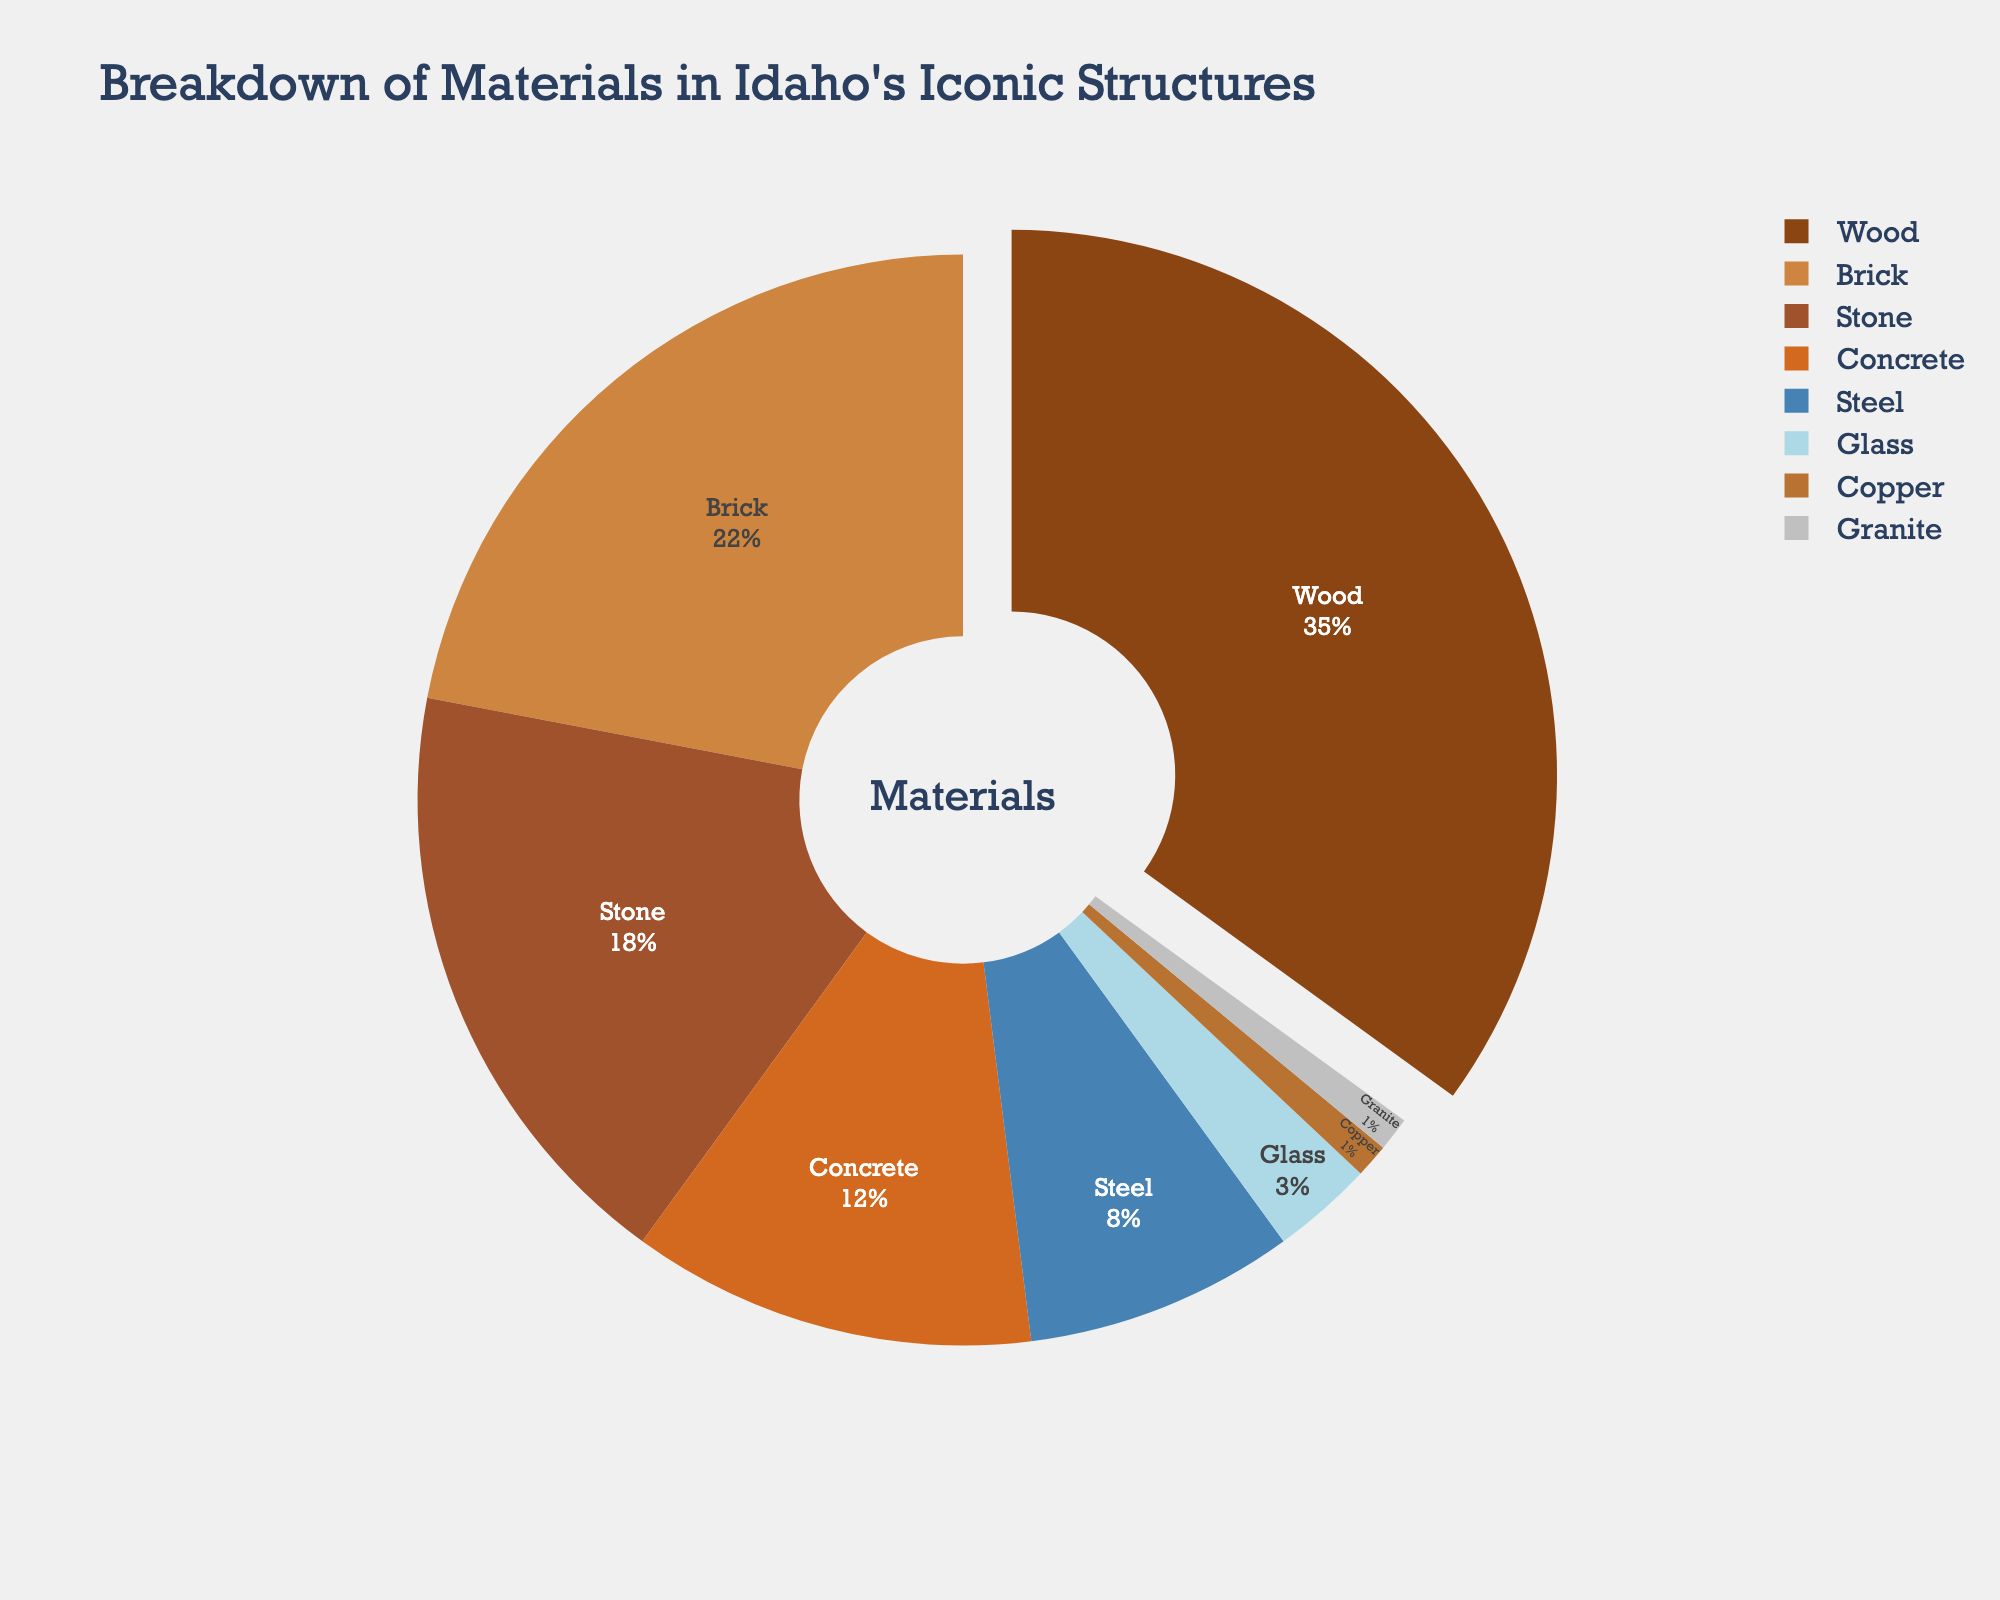What material is used the most in Idaho's iconic structures? The largest section of the pie chart represents the material that is used the most. The color associated with this section is brown, and the label indicates it is wood.
Answer: Wood Which material is used the least in Idaho's iconic structures? In a pie chart, the smallest segment represents the material that is used the least. The chart shows the smallest segments are copper and granite, both consisting of 1% each.
Answer: Copper and granite How much more percentage is wood used than steel? First, locate the percentage of wood (35%) and the percentage of steel (8%) from the chart. Then, subtract the percentage of steel from the percentage of wood: 35% - 8% = 27%.
Answer: 27% Are more structures built with stone or concrete? Compare the size of the segments labeled stone and concrete. The segment for stone (18%) is larger than that for concrete (12%).
Answer: Stone What is the combined percentage of materials that are used less than 5% each? Identify the materials that are used less than 5%: glass (3%), copper (1%), and granite (1%). Add these percentages: 3% + 1% + 1% = 5%.
Answer: 5% Which material comes third in terms of usage percentage? The third largest segment in the pie chart represents the material stone, which has an 18% usage.
Answer: Stone What is the difference in usage percentage between brick and concrete? From the chart, find the percentages for brick (22%) and concrete (12%). Subtract the percentage of concrete from the percentage of brick: 22% - 12% = 10%.
Answer: 10% How does the percentage of glass compare to the percentage of steel? The chart shows the percentage of glass is 3%, and the percentage of steel is 8%. Glass is used 5% less than steel.
Answer: 5% less What percentage of Idaho's iconic structures is made from metal materials (steel and copper)? Identify the percentages for steel (8%) and copper (1%) from the chart. Add these percentages together: 8% + 1% = 9%.
Answer: 9% Which material's segment is pulled out slightly from the rest in the pie chart, and why might this have been done? In the chart, the wood segment is pulled out slightly. This is likely done to emphasize that wood is used the most in Idaho's iconic structures.
Answer: Wood 